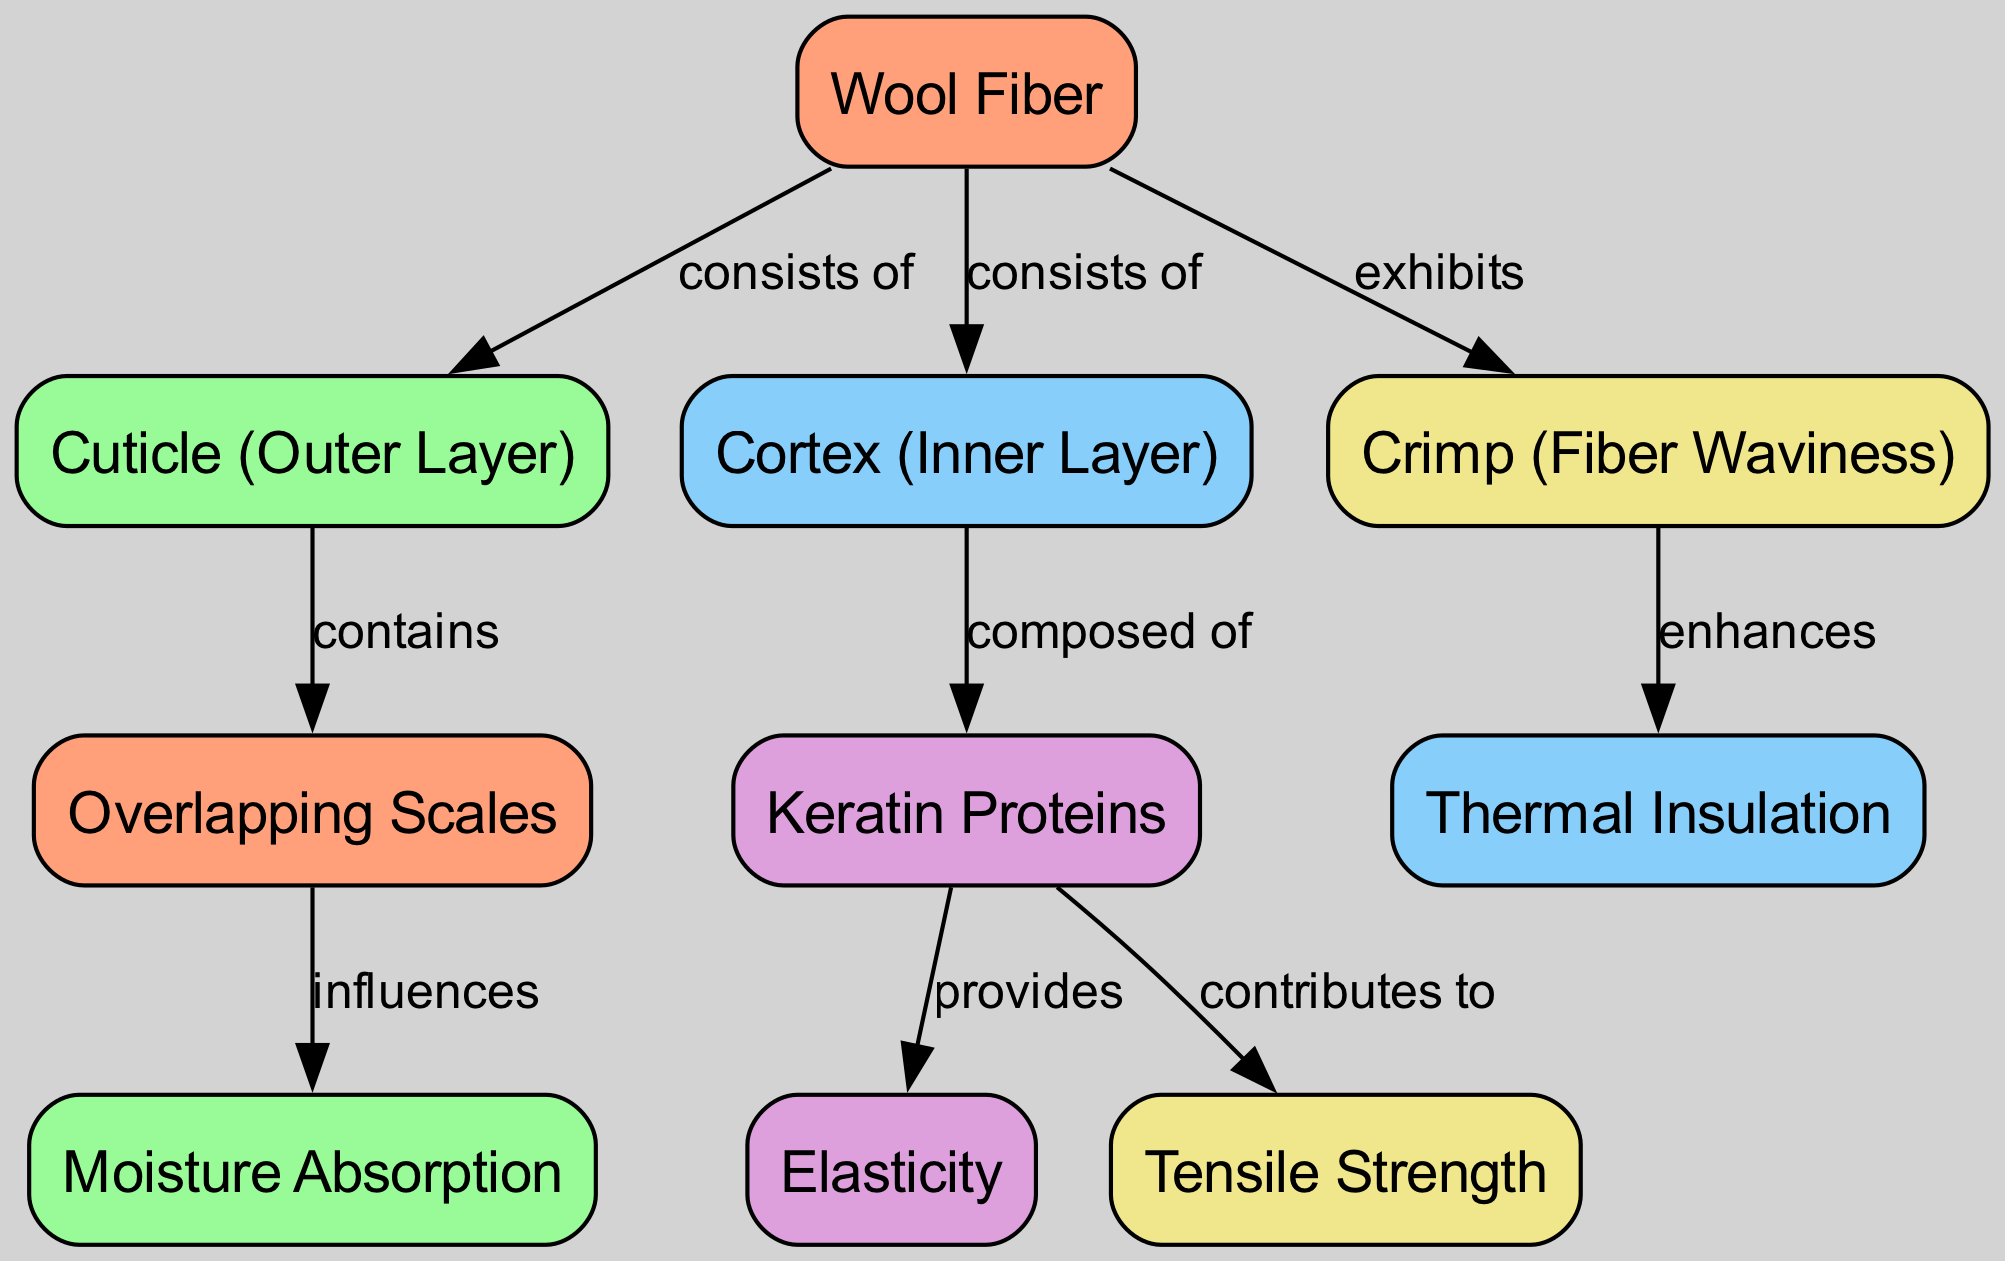What are the two main layers of Wool Fiber? The diagram identifies the two main layers of wool fiber as the "Cuticle (Outer Layer)" and the "Cortex (Inner Layer)," directly associated with the "Wool Fiber" node, which states it consists of these two layers.
Answer: Cuticle and Cortex How many microscopic components are indicated in the diagram? By counting the nodes listed in the diagram, there are a total of 10 components, which include the "Wool Fiber," "Cuticle," "Cortex," "Keratin," "Crimp," "Scales," "Moisture Absorption," "Thermal Insulation," "Elasticity," and "Tensile Strength."
Answer: 10 What property does the "Crimp" enhance? The diagram shows a direct influence of "Crimp (Fiber Waviness)" on "Thermal Insulation," indicating that crimp enhances this textile performance property.
Answer: Thermal Insulation What is the primary component of the Cortex? The diagram specifies that the "Cortex (Inner Layer)" is composed of "Keratin Proteins," which is the primary component associated with this layer.
Answer: Keratin Proteins How do Overlapping Scales impact the Wool Fiber? The diagram illustrates that "Overlapping Scales" influence "Moisture Absorption," establishing a relationship that shows how this specific microscopic structure affects the fiber's ability to absorb moisture.
Answer: Moisture Absorption What contributes to the Elasticity of wool fiber? According to the diagram, "Keratin Proteins" provide elasticity to wool fiber, which is directly linked to the components outlined in the concept map.
Answer: Keratin Proteins Which component is responsible for tensile strength? The diagram indicates that "Keratin" contributes to "Tensile Strength," establishing a relationship where keratin is identified as the responsible component for this property.
Answer: Keratin How does the structure of the Cuticle influence wool properties? The "Cuticle" contains "Overlapping Scales," and it is indicated in the diagram that these scales directly influence the property of "Moisture Absorption," suggesting the cuticle's structural aspects are crucial for wool's functional properties.
Answer: Moisture Absorption What effect does Fiber Waviness have on wool quality? It is shown in the diagram that "Crimp (Fiber Waviness)" enhances "Thermal Insulation," demonstrating how the waviness of wool fibers plays a critical role in improving wool's insulating capabilities.
Answer: Thermal Insulation 